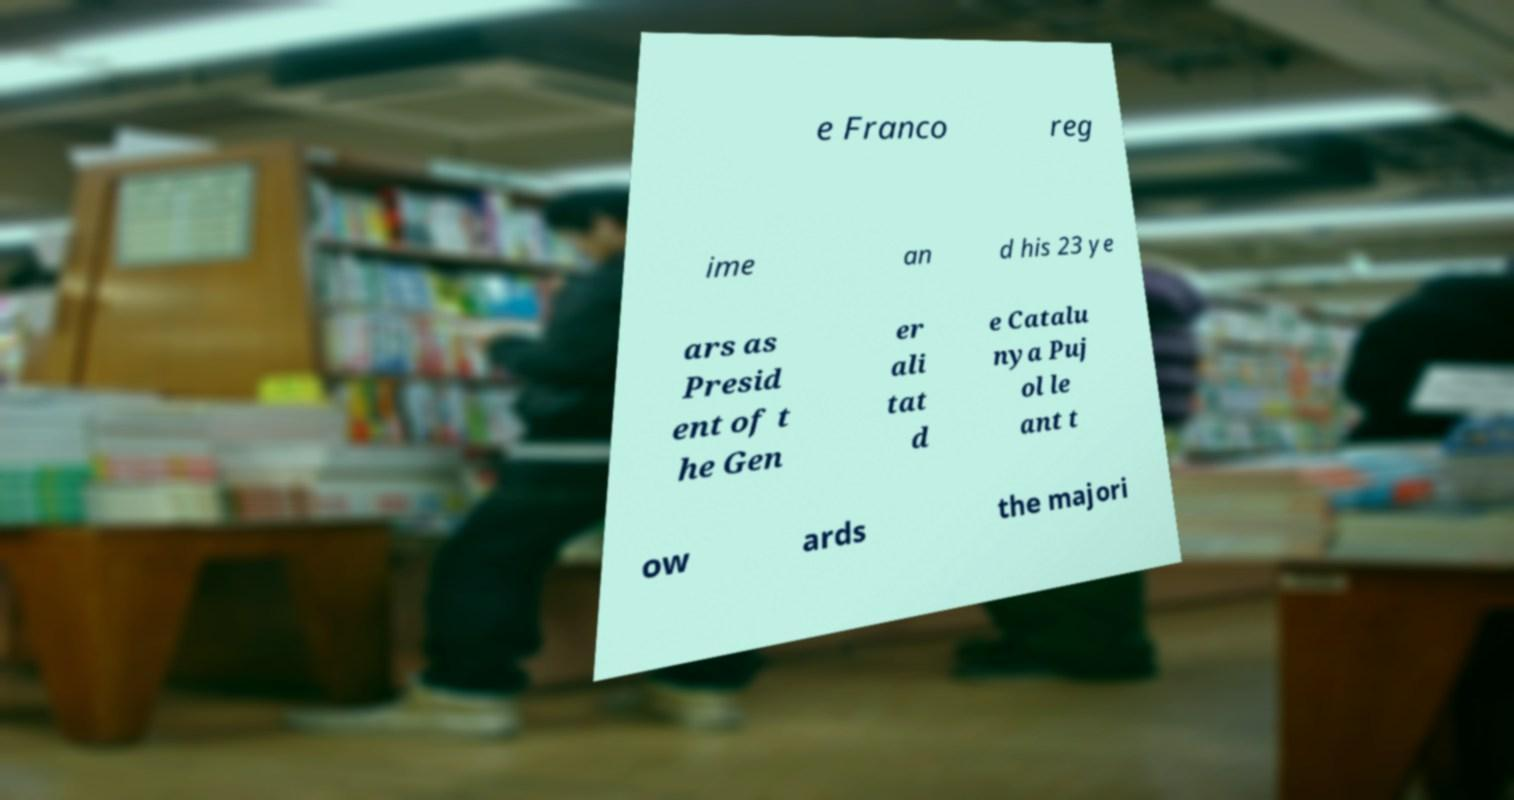Could you extract and type out the text from this image? e Franco reg ime an d his 23 ye ars as Presid ent of t he Gen er ali tat d e Catalu nya Puj ol le ant t ow ards the majori 